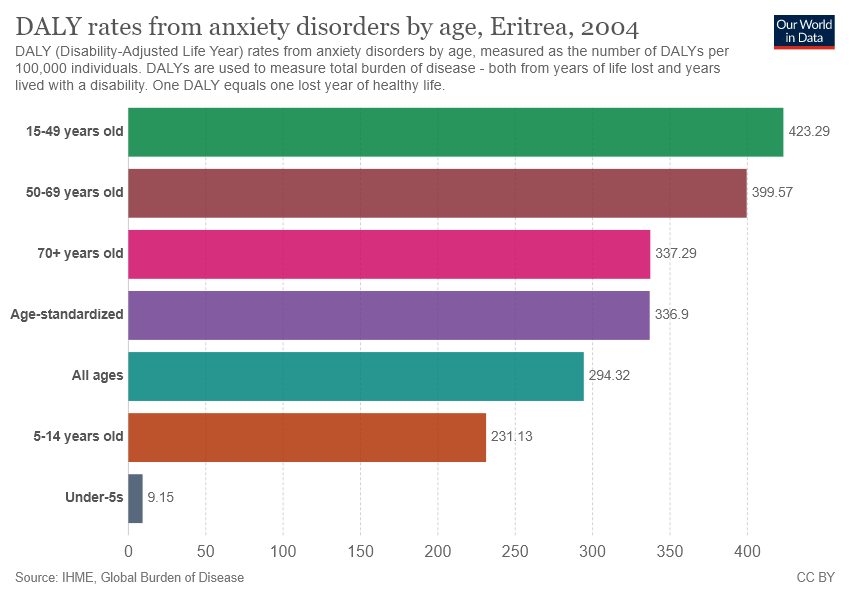Mention a couple of crucial points in this snapshot. According to the data, the maximum and minimum rates of anxiety disorders vary significantly across different age groups. Specifically, the maximum rate was 414.14, while the minimum rate was 1.44. The pink color is representative of the age group of 70 years old and above. 